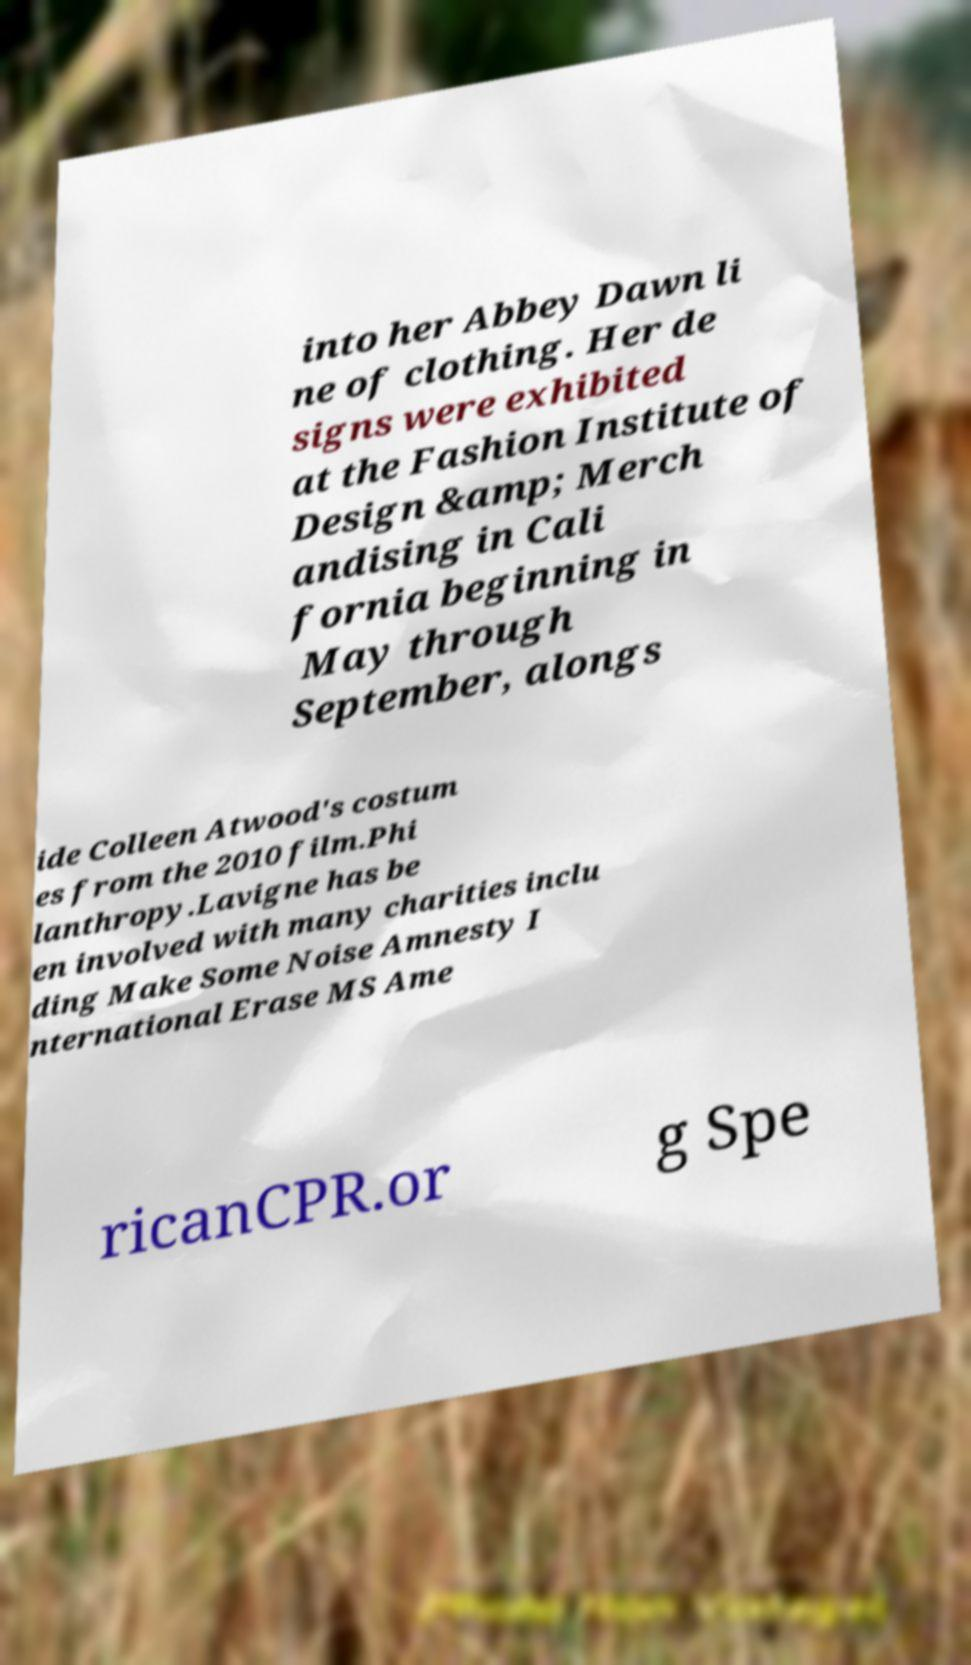Could you assist in decoding the text presented in this image and type it out clearly? into her Abbey Dawn li ne of clothing. Her de signs were exhibited at the Fashion Institute of Design &amp; Merch andising in Cali fornia beginning in May through September, alongs ide Colleen Atwood's costum es from the 2010 film.Phi lanthropy.Lavigne has be en involved with many charities inclu ding Make Some Noise Amnesty I nternational Erase MS Ame ricanCPR.or g Spe 